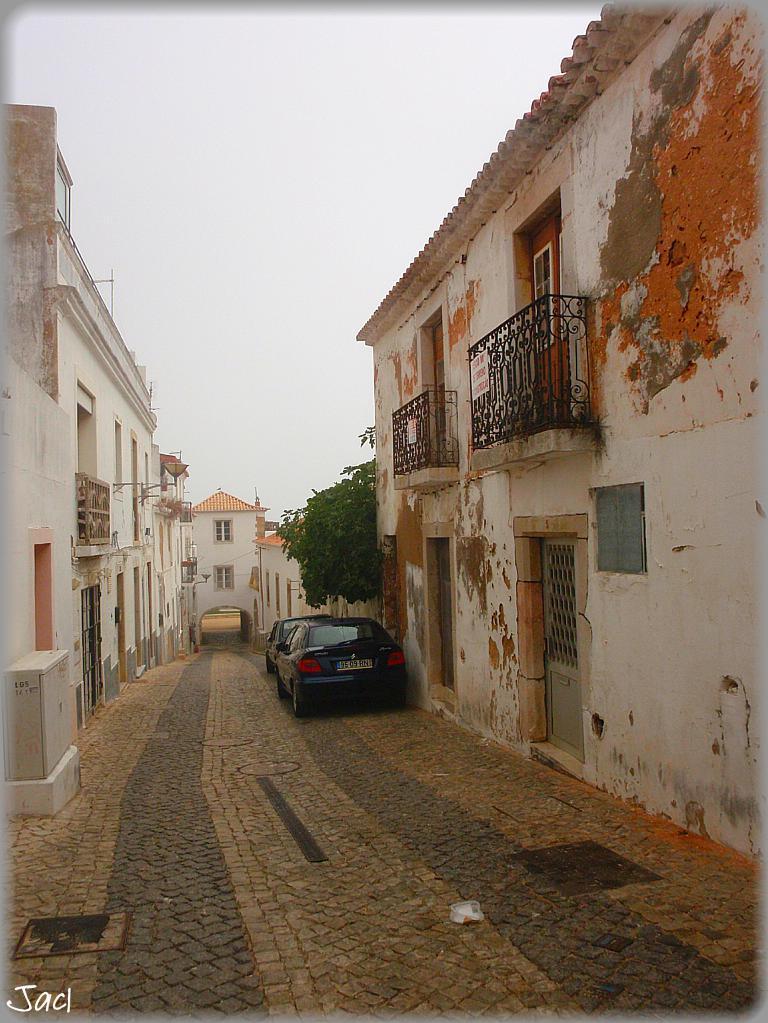Could you give a brief overview of what you see in this image? This picture is clicked outside. On both the sides we can see the buildings. In the foreground we can see the pavement. On the right we can see the cars and a tree. In the background we can see the sky, buildings, railings and some other objects. In the bottom left corner we can see the text on the image. 